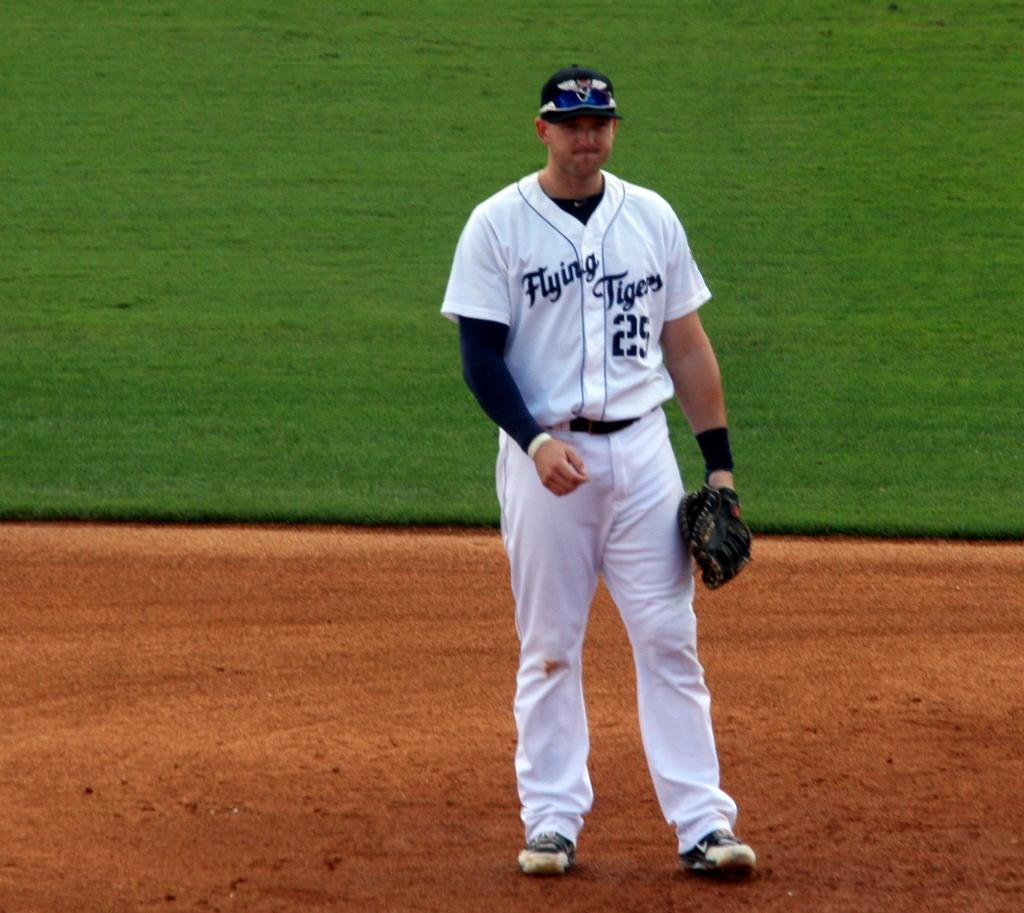<image>
Write a terse but informative summary of the picture. a person playing baseball with the word flying on his jersey 